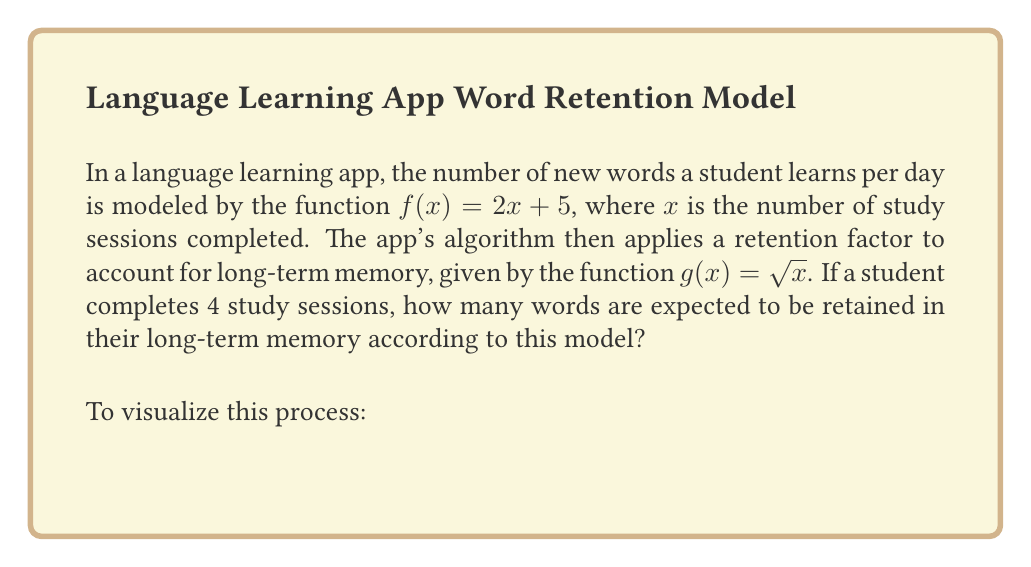Can you solve this math problem? Let's approach this step-by-step using function composition:

1) First, we need to find $f(4)$, which represents the number of new words learned after 4 study sessions:

   $f(4) = 2(4) + 5 = 8 + 5 = 13$

2) Now, we need to apply the retention factor to this result. This is where function composition comes in. We're essentially calculating $g(f(4))$:

   $g(f(4)) = g(13) = \sqrt{13}$

3) To simplify this further:

   $\sqrt{13} \approx 3.61$

4) Since we're dealing with words, we need to round down to the nearest whole number:

   $\lfloor \sqrt{13} \rfloor = 3$

Therefore, according to this model, a student who completes 4 study sessions is expected to retain 3 words in their long-term memory.

This problem demonstrates how function composition $(g \circ f)(x) = g(f(x))$ can be used to model complex real-world scenarios, in this case, the learning and retention of new vocabulary words.
Answer: 3 words 